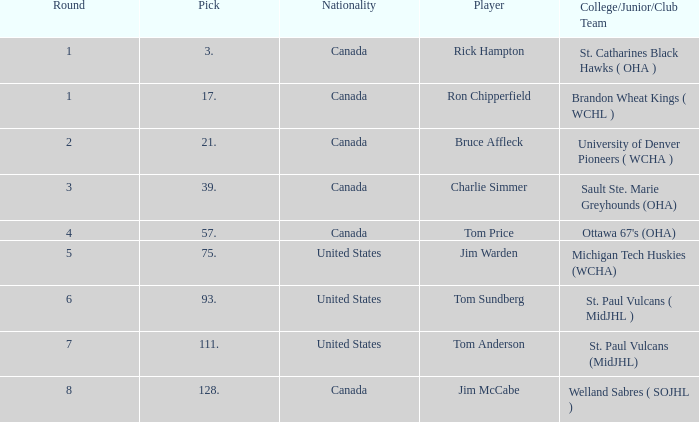Can you tell me the Nationality that has the Round smaller than 5, and the Player of bruce affleck? Canada. Help me parse the entirety of this table. {'header': ['Round', 'Pick', 'Nationality', 'Player', 'College/Junior/Club Team'], 'rows': [['1', '3.', 'Canada', 'Rick Hampton', 'St. Catharines Black Hawks ( OHA )'], ['1', '17.', 'Canada', 'Ron Chipperfield', 'Brandon Wheat Kings ( WCHL )'], ['2', '21.', 'Canada', 'Bruce Affleck', 'University of Denver Pioneers ( WCHA )'], ['3', '39.', 'Canada', 'Charlie Simmer', 'Sault Ste. Marie Greyhounds (OHA)'], ['4', '57.', 'Canada', 'Tom Price', "Ottawa 67's (OHA)"], ['5', '75.', 'United States', 'Jim Warden', 'Michigan Tech Huskies (WCHA)'], ['6', '93.', 'United States', 'Tom Sundberg', 'St. Paul Vulcans ( MidJHL )'], ['7', '111.', 'United States', 'Tom Anderson', 'St. Paul Vulcans (MidJHL)'], ['8', '128.', 'Canada', 'Jim McCabe', 'Welland Sabres ( SOJHL )']]} 